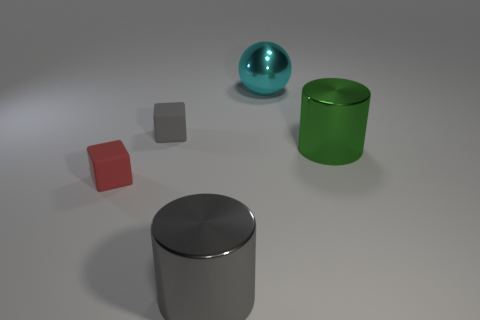There is a tiny rubber thing that is to the left of the gray cube; is it the same shape as the big green thing?
Provide a short and direct response. No. Are there fewer rubber blocks that are behind the green shiny cylinder than tiny red matte cylinders?
Your response must be concise. No. Are there any small red objects made of the same material as the gray block?
Make the answer very short. Yes. What material is the green object that is the same size as the cyan metallic object?
Your answer should be compact. Metal. Is the number of red objects that are on the right side of the cyan thing less than the number of large green metallic cylinders left of the red rubber object?
Make the answer very short. No. What shape is the object that is both behind the red object and on the left side of the big cyan metallic ball?
Keep it short and to the point. Cube. How many other tiny things have the same shape as the small gray matte thing?
Provide a short and direct response. 1. There is a cyan sphere that is made of the same material as the large green cylinder; what is its size?
Offer a very short reply. Large. Are there more big green cylinders than small things?
Your response must be concise. No. There is a large shiny cylinder left of the cyan metal thing; what color is it?
Provide a short and direct response. Gray. 